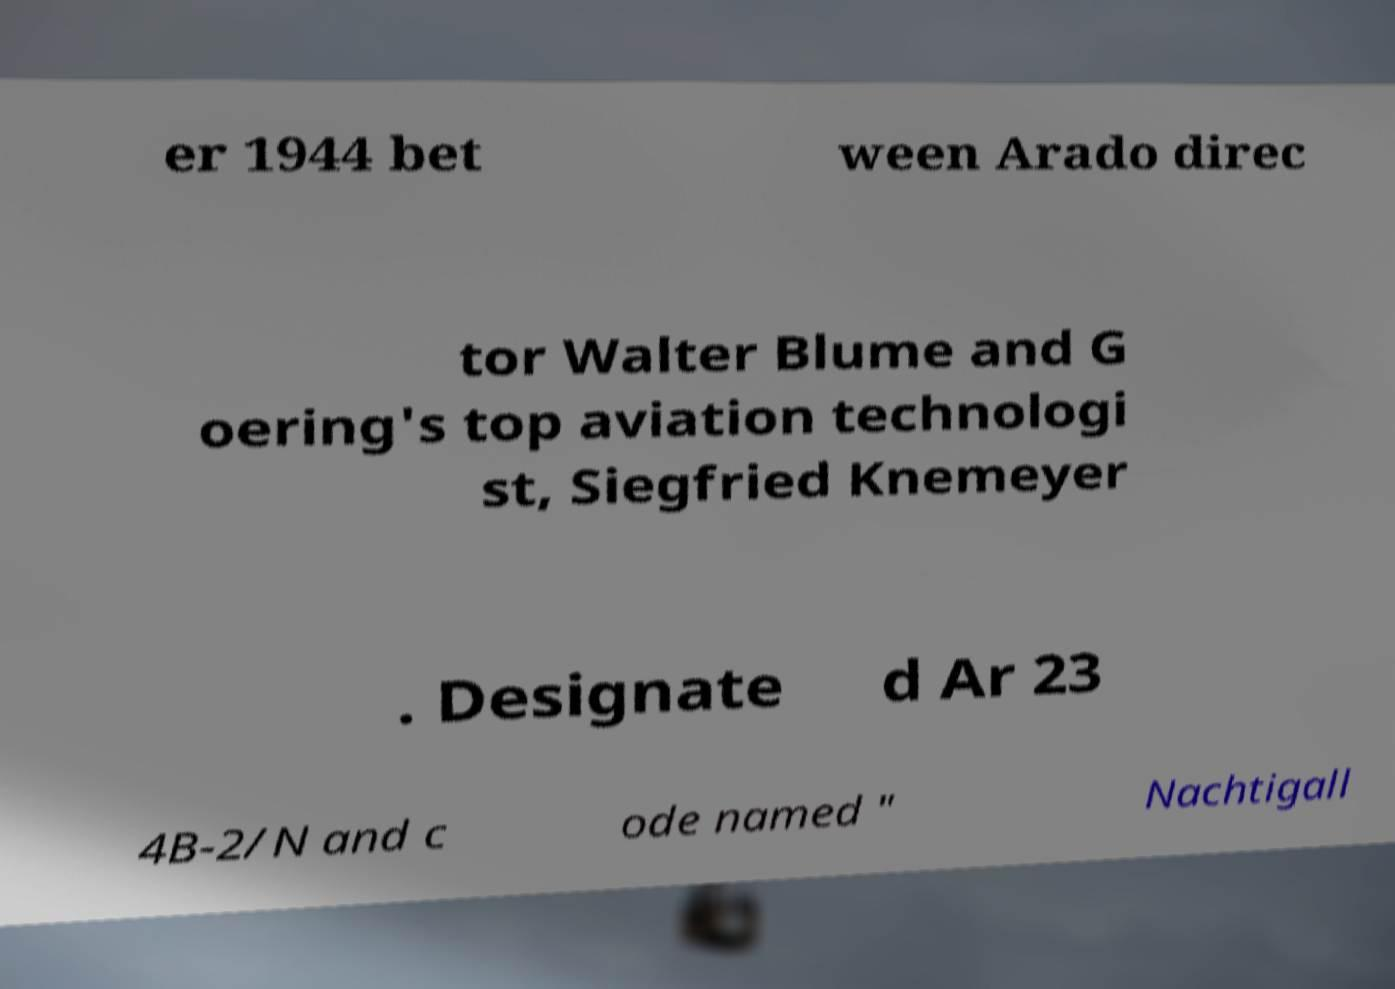Can you read and provide the text displayed in the image?This photo seems to have some interesting text. Can you extract and type it out for me? er 1944 bet ween Arado direc tor Walter Blume and G oering's top aviation technologi st, Siegfried Knemeyer . Designate d Ar 23 4B-2/N and c ode named " Nachtigall 